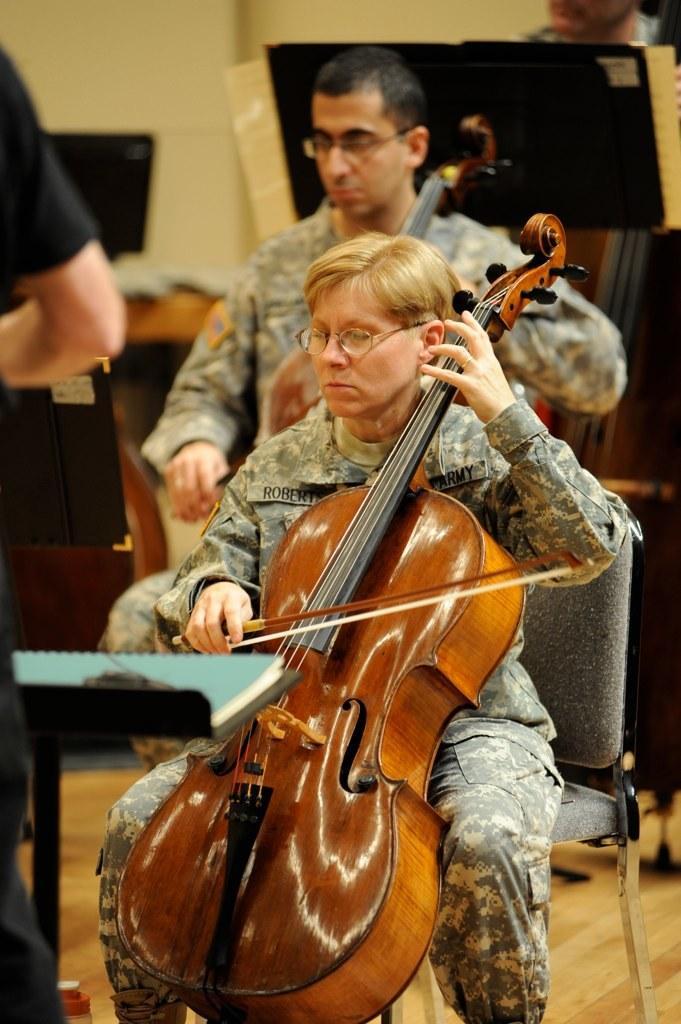Describe this image in one or two sentences. This picture shows two people seated on chairs and playing violin and a person standing 